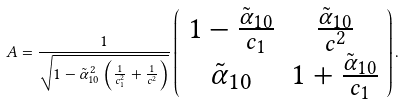Convert formula to latex. <formula><loc_0><loc_0><loc_500><loc_500>A = \frac { 1 } { \sqrt { 1 - \tilde { \alpha } ^ { 2 } _ { 1 0 } \left ( \frac { 1 } { c _ { 1 } ^ { 2 } } + \frac { 1 } { c ^ { 2 } } \right ) } } \left ( \begin{array} { c c } 1 - \frac { \tilde { \alpha } _ { 1 0 } } { c _ { 1 } } & \frac { \tilde { \alpha } _ { 1 0 } } { c ^ { 2 } } \\ \tilde { \alpha } _ { 1 0 } & 1 + \frac { \tilde { \alpha } _ { 1 0 } } { c _ { 1 } } \end{array} \right ) .</formula> 